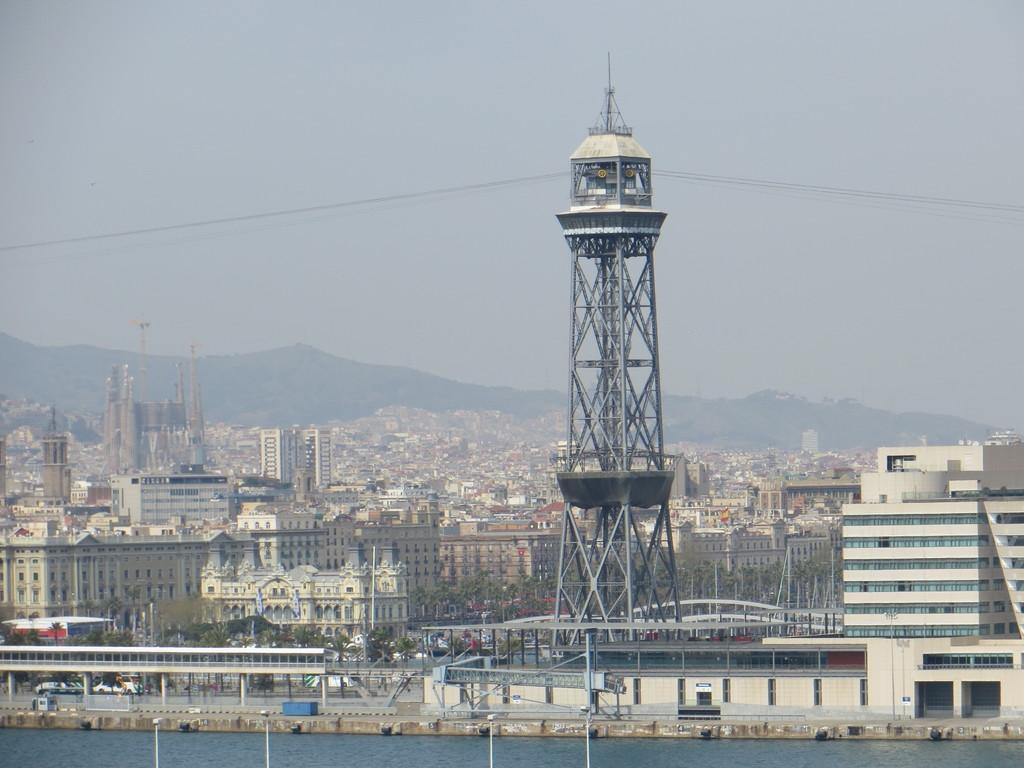Describe this image in one or two sentences. In this image we can see many buildings. There is a tower in the image. There are few cables in the image. There are many trees in the image. We can see the sky in the image. We can see the water at the bottom of the image. There are few vehicles at the left side of the image. 